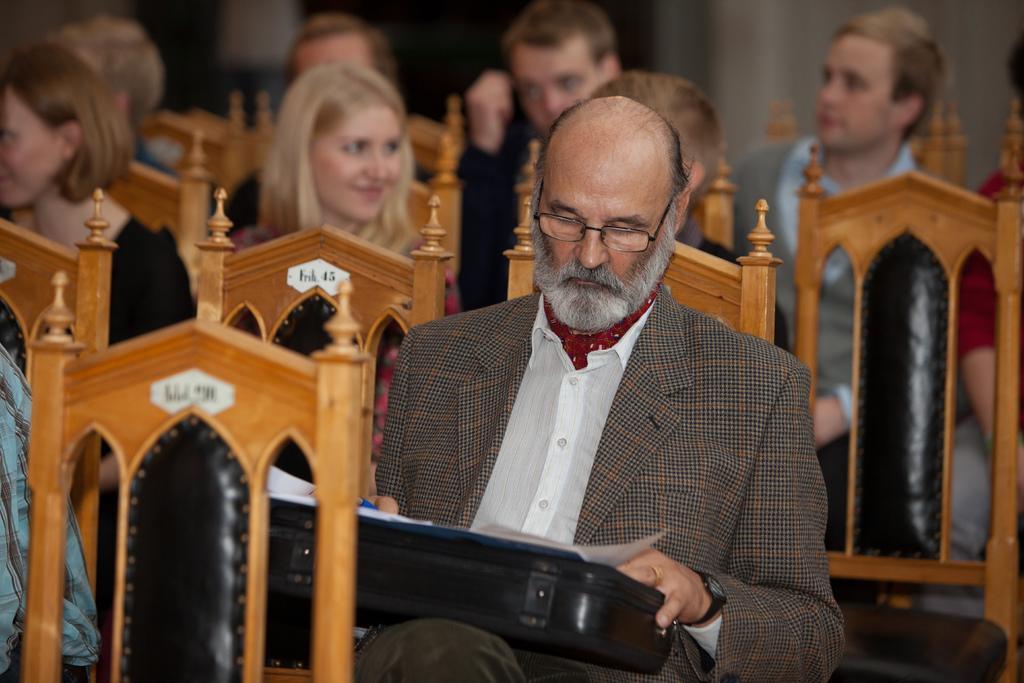Could you give a brief overview of what you see in this image? In the image there are few people being seated on the chairs and among all of them the person who is holding a briefcase is highlighted in the picture. 